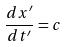Convert formula to latex. <formula><loc_0><loc_0><loc_500><loc_500>\frac { d x ^ { \prime } } { d t ^ { \prime } } = c</formula> 